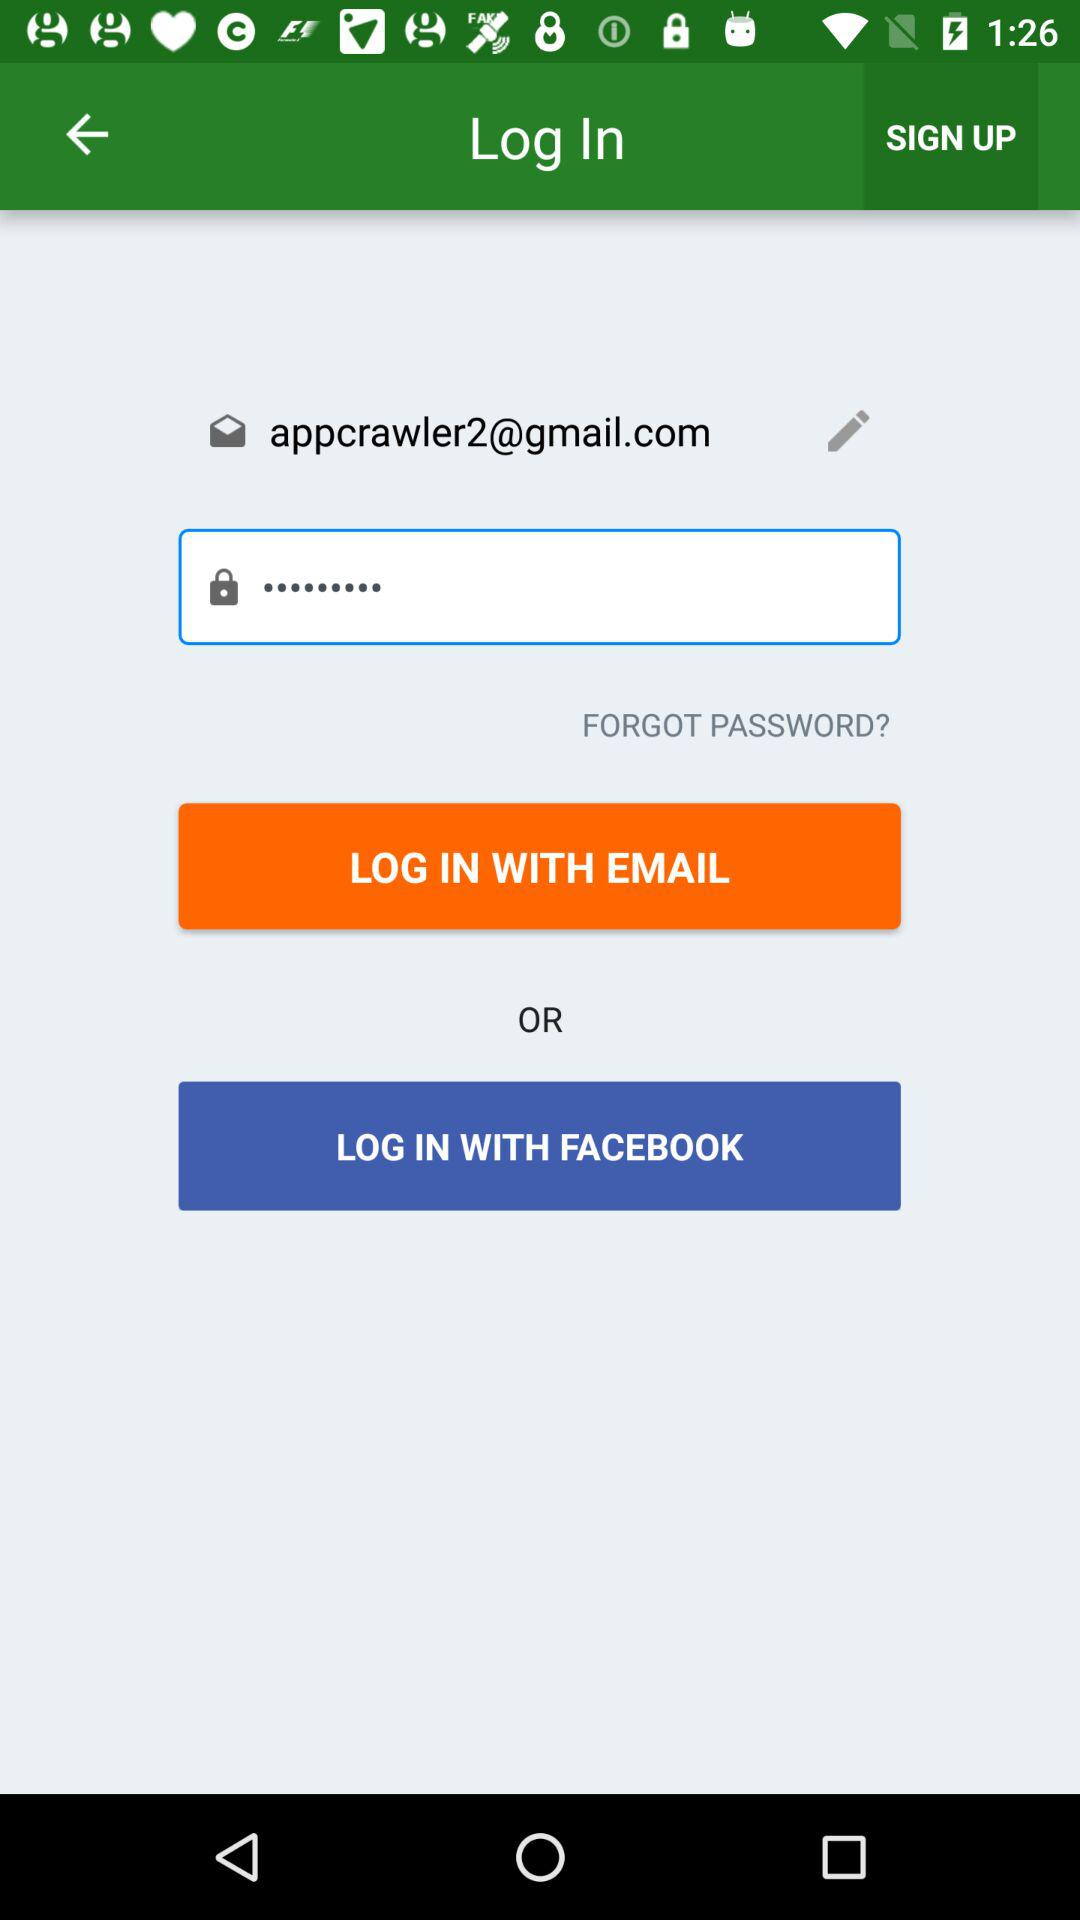Can we reset password?
When the provided information is insufficient, respond with <no answer>. <no answer> 